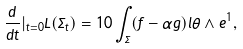Convert formula to latex. <formula><loc_0><loc_0><loc_500><loc_500>\frac { d } { d t } | _ { t = 0 } L ( \Sigma _ { t } ) = 1 0 \int _ { \Sigma } ( f - \alpha g ) l \theta \wedge e ^ { 1 } ,</formula> 